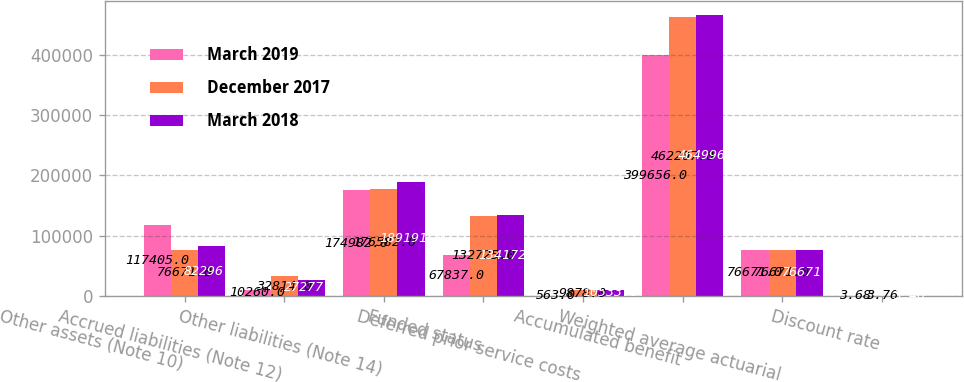<chart> <loc_0><loc_0><loc_500><loc_500><stacked_bar_chart><ecel><fcel>Other assets (Note 10)<fcel>Accrued liabilities (Note 12)<fcel>Other liabilities (Note 14)<fcel>Funded status<fcel>Deferred prior service costs<fcel>Accumulated benefit<fcel>Weighted average actuarial<fcel>Discount rate<nl><fcel>March 2019<fcel>117405<fcel>10260<fcel>174982<fcel>67837<fcel>563<fcel>399656<fcel>76671<fcel>3.68<nl><fcel>December 2017<fcel>76671<fcel>32814<fcel>176582<fcel>132725<fcel>9878<fcel>462207<fcel>76671<fcel>3.76<nl><fcel>March 2018<fcel>82296<fcel>27277<fcel>189191<fcel>134172<fcel>10533<fcel>464996<fcel>76671<fcel>3.46<nl></chart> 